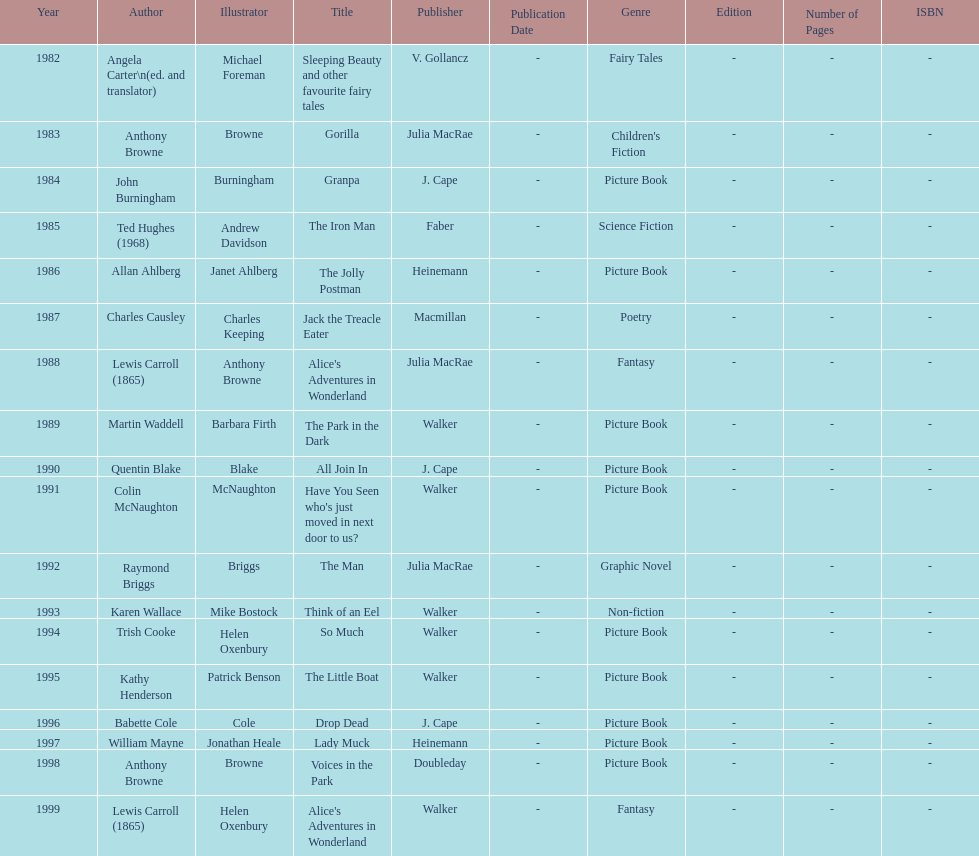What is the only title listed for 1999? Alice's Adventures in Wonderland. 